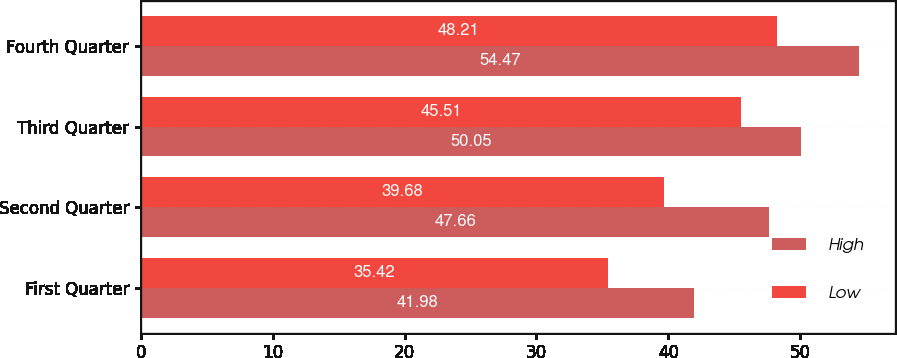Convert chart to OTSL. <chart><loc_0><loc_0><loc_500><loc_500><stacked_bar_chart><ecel><fcel>First Quarter<fcel>Second Quarter<fcel>Third Quarter<fcel>Fourth Quarter<nl><fcel>High<fcel>41.98<fcel>47.66<fcel>50.05<fcel>54.47<nl><fcel>Low<fcel>35.42<fcel>39.68<fcel>45.51<fcel>48.21<nl></chart> 